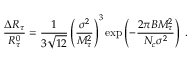<formula> <loc_0><loc_0><loc_500><loc_500>\frac { \Delta R _ { \tau } } { R _ { \tau } ^ { 0 } } = \frac { 1 } { 3 \sqrt { 1 2 } } \left ( \frac { \sigma ^ { 2 } } { M _ { \tau } ^ { 2 } } \right ) ^ { 3 } { \exp } \left ( - \frac { 2 \pi B M _ { \tau } ^ { 2 } } { N _ { c } \sigma ^ { 2 } } \right ) \, .</formula> 